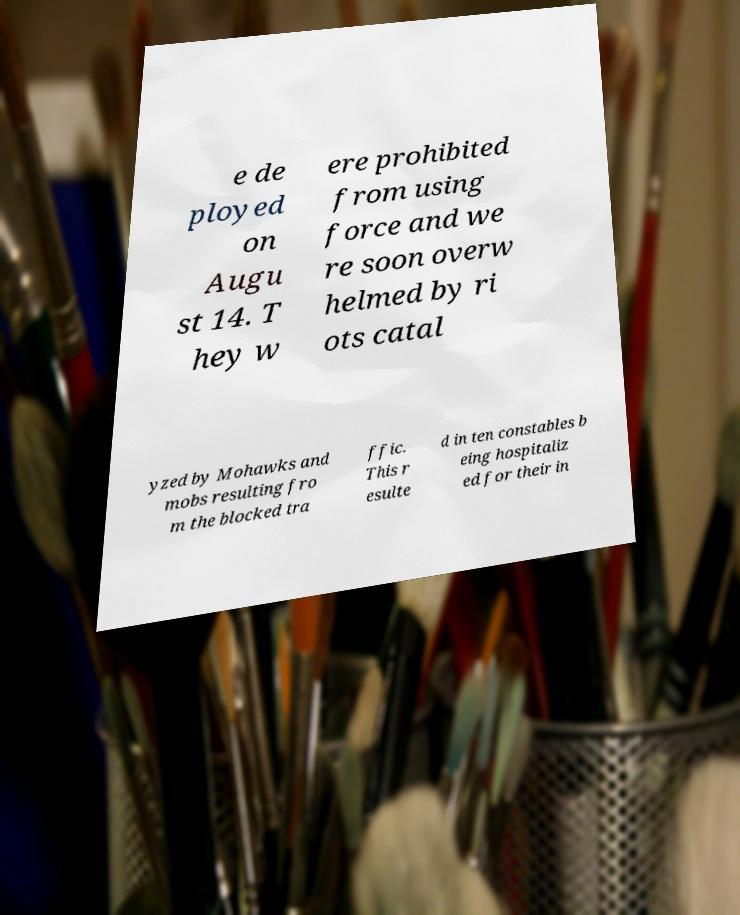For documentation purposes, I need the text within this image transcribed. Could you provide that? e de ployed on Augu st 14. T hey w ere prohibited from using force and we re soon overw helmed by ri ots catal yzed by Mohawks and mobs resulting fro m the blocked tra ffic. This r esulte d in ten constables b eing hospitaliz ed for their in 